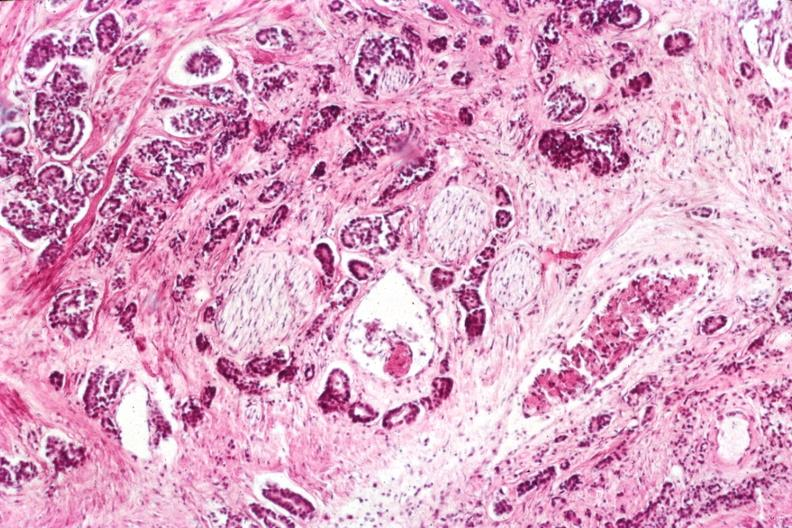s adenocarcinoma present?
Answer the question using a single word or phrase. Yes 